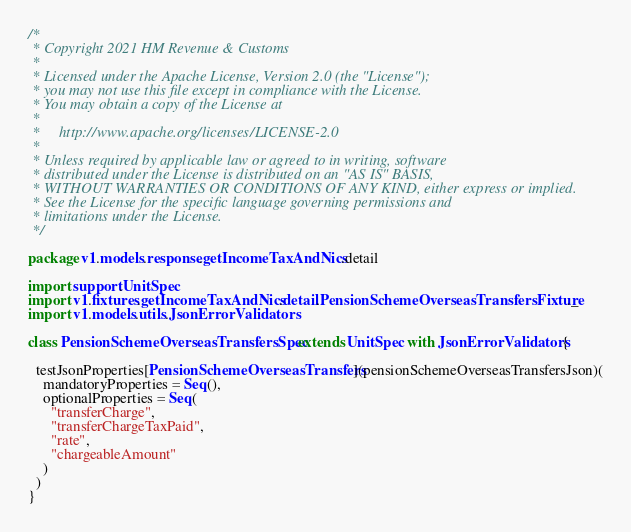<code> <loc_0><loc_0><loc_500><loc_500><_Scala_>/*
 * Copyright 2021 HM Revenue & Customs
 *
 * Licensed under the Apache License, Version 2.0 (the "License");
 * you may not use this file except in compliance with the License.
 * You may obtain a copy of the License at
 *
 *     http://www.apache.org/licenses/LICENSE-2.0
 *
 * Unless required by applicable law or agreed to in writing, software
 * distributed under the License is distributed on an "AS IS" BASIS,
 * WITHOUT WARRANTIES OR CONDITIONS OF ANY KIND, either express or implied.
 * See the License for the specific language governing permissions and
 * limitations under the License.
 */

package v1.models.response.getIncomeTaxAndNics.detail

import support.UnitSpec
import v1.fixtures.getIncomeTaxAndNics.detail.PensionSchemeOverseasTransfersFixture._
import v1.models.utils.JsonErrorValidators

class PensionSchemeOverseasTransfersSpec extends UnitSpec with JsonErrorValidators {

  testJsonProperties[PensionSchemeOverseasTransfers](pensionSchemeOverseasTransfersJson)(
    mandatoryProperties = Seq(),
    optionalProperties = Seq(
      "transferCharge",
      "transferChargeTaxPaid",
      "rate",
      "chargeableAmount"
    )
  )
}</code> 